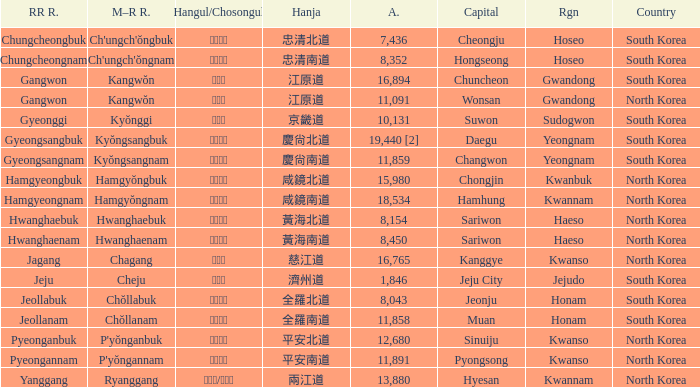What is the area for the province having Hangul of 경기도? 10131.0. 